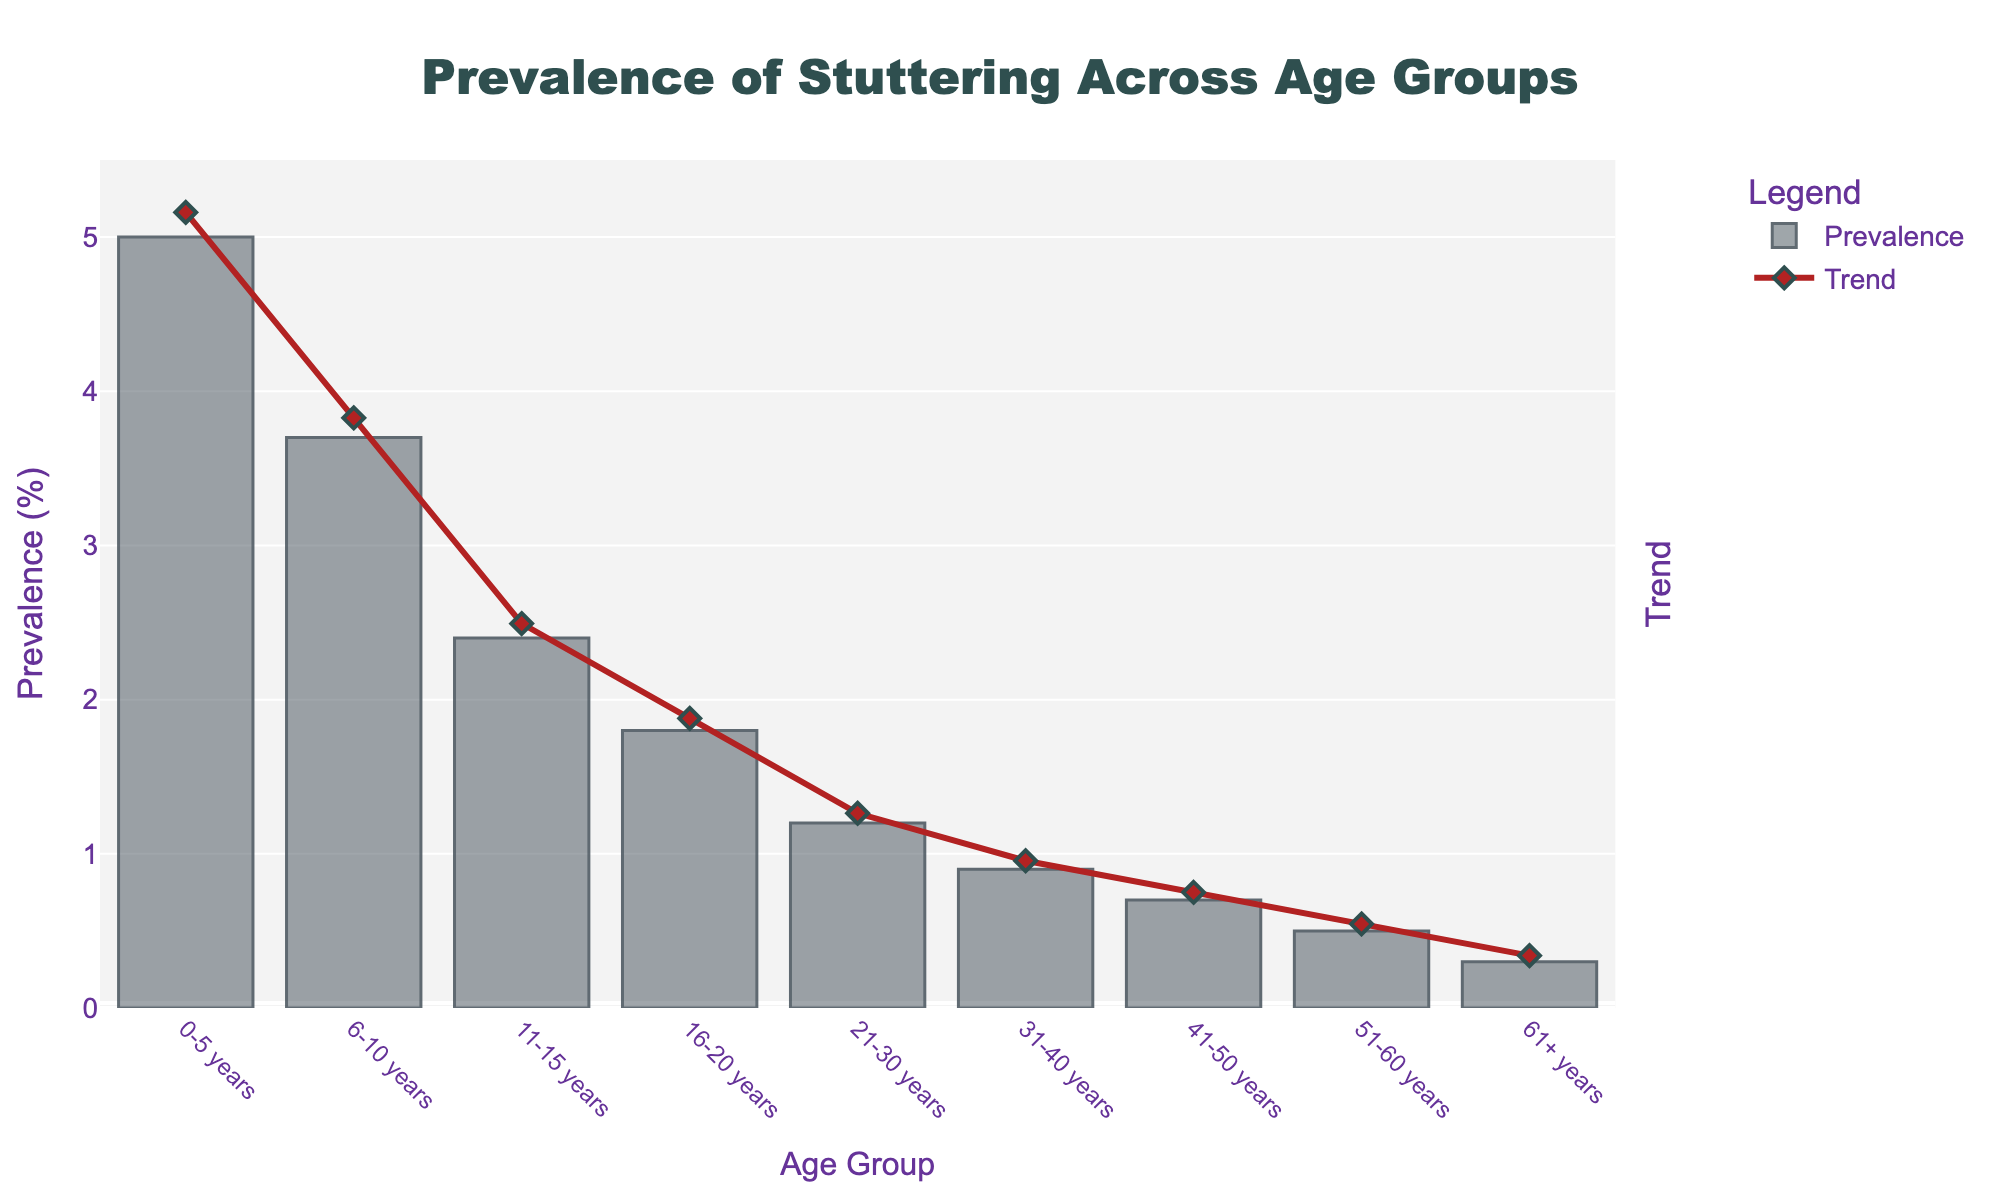Which age group has the highest prevalence of stuttering? The highest prevalence of stuttering can be determined by looking at the tallest bar in the chart. The bar representing the 0-5 years age group is the tallest.
Answer: 0-5 years Which age group has the lowest prevalence of stuttering? The lowest prevalence of stuttering is represented by the shortest bar in the chart. The bar for the 61+ years age group is the shortest.
Answer: 61+ years How does the prevalence of stuttering for the 21-30 years age group compare to the 31-40 years age group? Compare the heights of the bars representing these two age groups. The bar for 21-30 years is slightly taller than the bar for 31-40 years.
Answer: Higher What is the trend in prevalence of stuttering as age increases? Observing the overall shape formed by the bars and the trend line in the chart, we can see that the prevalence of stuttering generally decreases as age increases.
Answer: Decreasing What is the difference in prevalence of stuttering between the 0-5 years age group and the 61+ years age group? Subtract the prevalence of the 61+ years age group (0.3%) from the 0-5 years age group (5.0%).
Answer: 4.7% What is the sum of the prevalence percentages for the age groups 0-5 years and 6-10 years? Add the prevalence percentages of the 0-5 years (5.0%) and 6-10 years (3.7%) age groups.
Answer: 8.7% Which age groups have a prevalence of stuttering above 2%? Identify the bars that are taller than the 2% mark. The age groups 0-5 years, 6-10 years, and 11-15 years fall into this category.
Answer: 0-5 years, 6-10 years, 11-15 years Is the decrease in prevalence more pronounced between any two consecutive age groups? Examine the bars and the trend line to identify which consecutive age groups show the most significant drop in prevalence. The most pronounced decrease occurs between the 0-5 years (5.0%) and 6-10 years (3.7%) age groups.
Answer: 0-5 years to 6-10 years 